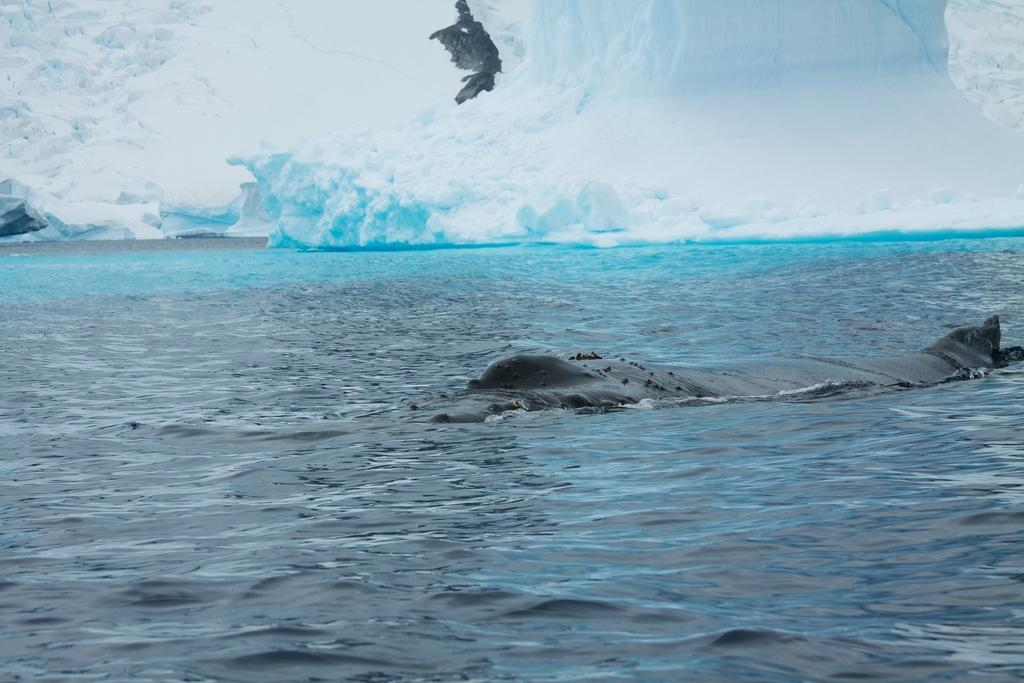What is the animal doing in the water? The fact provided does not specify what the animal is doing in the water. What type of environment is suggested by the presence of snow in the background? The presence of snow in the background suggests a cold or wintery environment. What type of wall can be seen in the image? There is no wall present in the image; it features an animal in the water with snow in the background. 